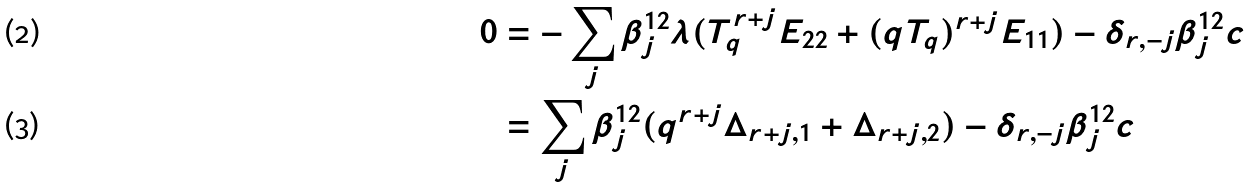Convert formula to latex. <formula><loc_0><loc_0><loc_500><loc_500>\, 0 & = - \sum _ { j } \beta _ { j } ^ { 1 2 } \lambda ( T _ { q } ^ { r + j } E _ { 2 2 } + ( q T _ { q } ) ^ { r + j } E _ { 1 1 } ) - \delta _ { r , - j } \beta _ { j } ^ { 1 2 } c \\ \, & = \sum _ { j } \beta _ { j } ^ { 1 2 } ( q ^ { r + j } \Delta _ { r + j , 1 } + \Delta _ { r + j , 2 } ) - \delta _ { r , - j } \beta _ { j } ^ { 1 2 } c</formula> 